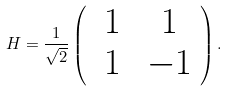<formula> <loc_0><loc_0><loc_500><loc_500>H = \frac { 1 } { \sqrt { 2 } } \left ( \begin{array} { c c } \ 1 & \ 1 \\ \ 1 & \ - 1 \end{array} \right ) .</formula> 